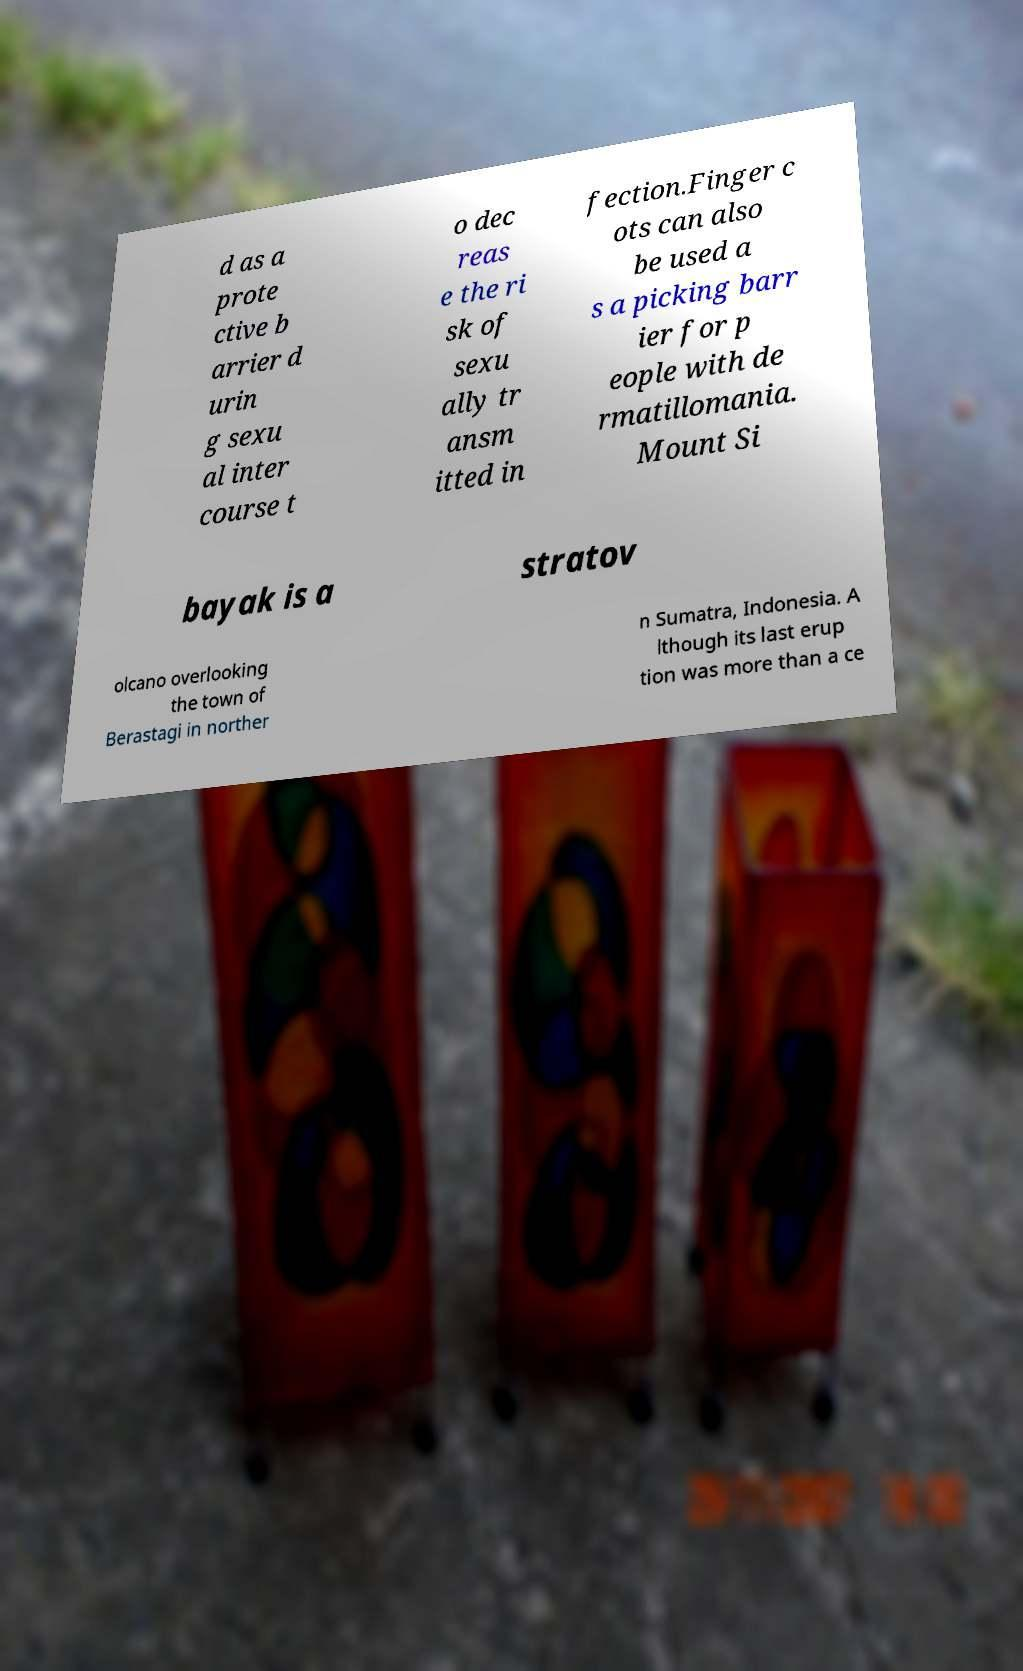What messages or text are displayed in this image? I need them in a readable, typed format. d as a prote ctive b arrier d urin g sexu al inter course t o dec reas e the ri sk of sexu ally tr ansm itted in fection.Finger c ots can also be used a s a picking barr ier for p eople with de rmatillomania. Mount Si bayak is a stratov olcano overlooking the town of Berastagi in norther n Sumatra, Indonesia. A lthough its last erup tion was more than a ce 